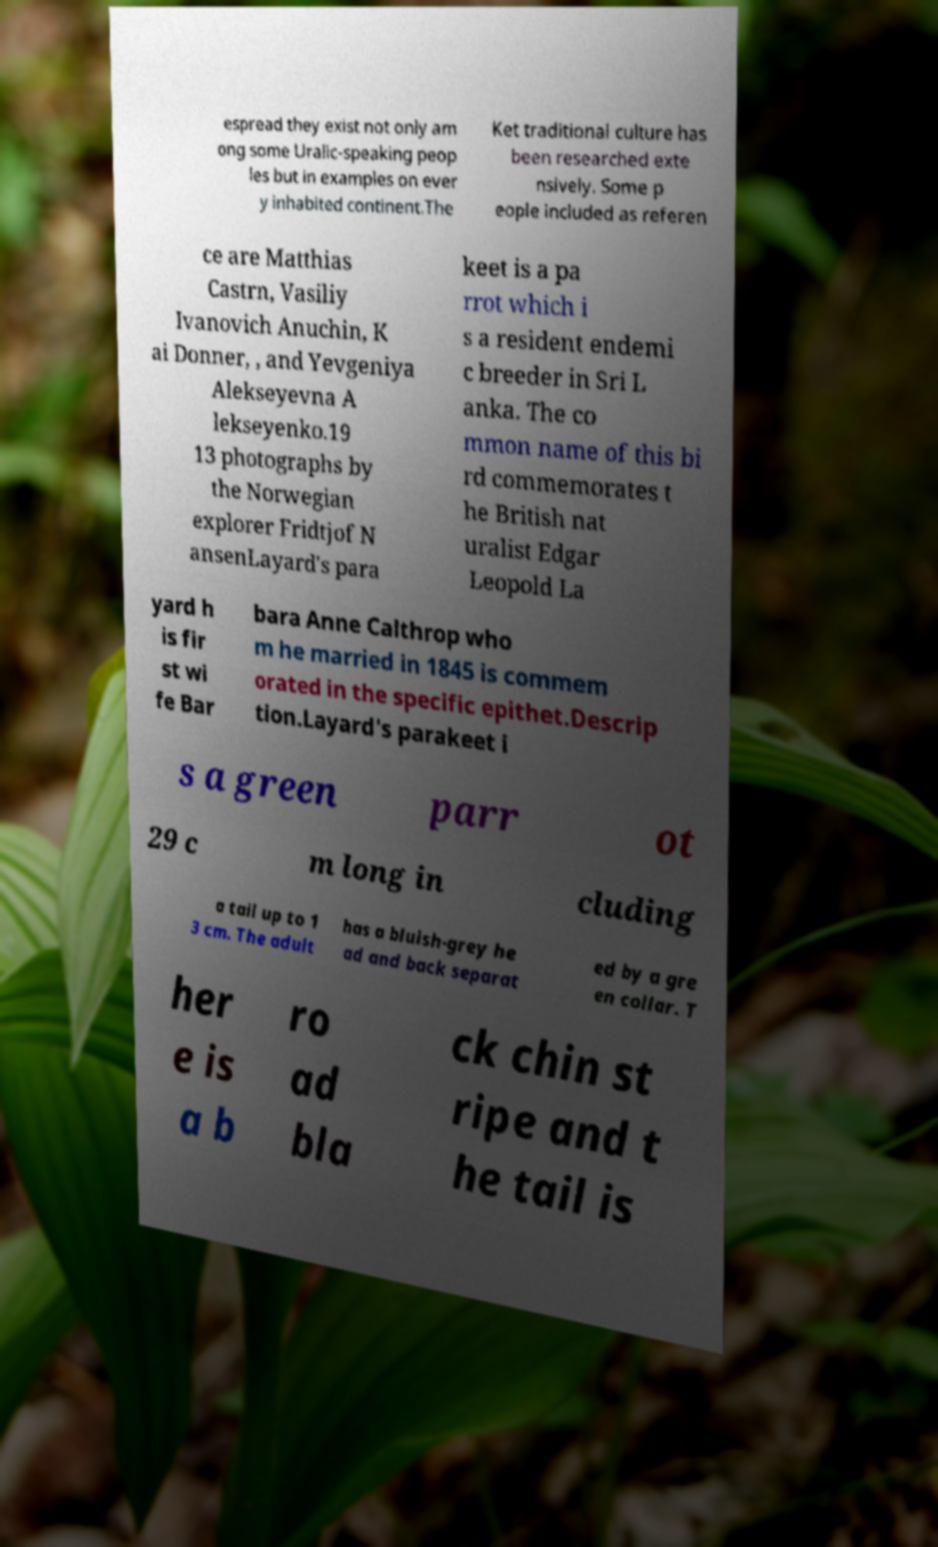Can you read and provide the text displayed in the image?This photo seems to have some interesting text. Can you extract and type it out for me? espread they exist not only am ong some Uralic-speaking peop les but in examples on ever y inhabited continent.The Ket traditional culture has been researched exte nsively. Some p eople included as referen ce are Matthias Castrn, Vasiliy Ivanovich Anuchin, K ai Donner, , and Yevgeniya Alekseyevna A lekseyenko.19 13 photographs by the Norwegian explorer Fridtjof N ansenLayard's para keet is a pa rrot which i s a resident endemi c breeder in Sri L anka. The co mmon name of this bi rd commemorates t he British nat uralist Edgar Leopold La yard h is fir st wi fe Bar bara Anne Calthrop who m he married in 1845 is commem orated in the specific epithet.Descrip tion.Layard's parakeet i s a green parr ot 29 c m long in cluding a tail up to 1 3 cm. The adult has a bluish-grey he ad and back separat ed by a gre en collar. T her e is a b ro ad bla ck chin st ripe and t he tail is 